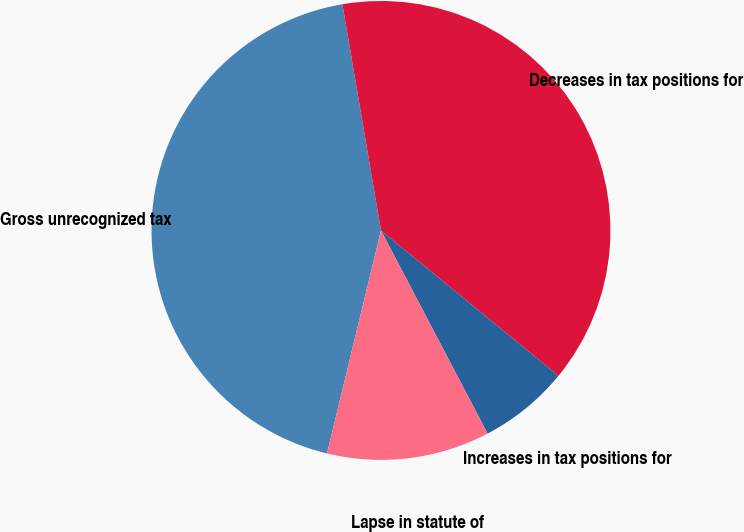Convert chart to OTSL. <chart><loc_0><loc_0><loc_500><loc_500><pie_chart><fcel>Gross unrecognized tax<fcel>Decreases in tax positions for<fcel>Increases in tax positions for<fcel>Lapse in statute of<nl><fcel>43.53%<fcel>38.61%<fcel>6.38%<fcel>11.47%<nl></chart> 